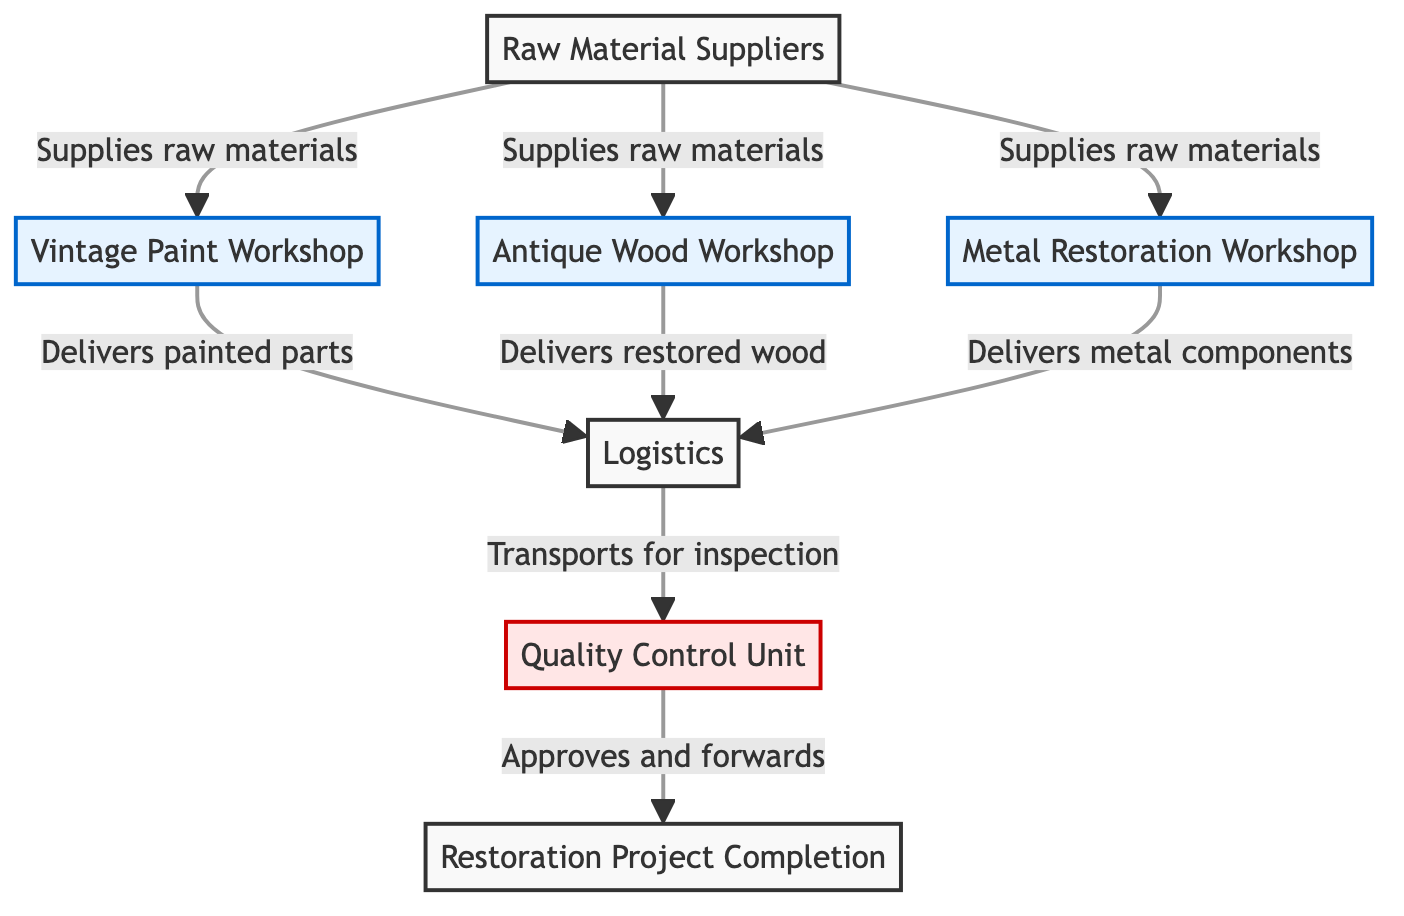What are the main components in the restoration food chain? The diagram includes four main components: Raw Material Suppliers, three workshops (Vintage Paint Workshop, Antique Wood Workshop, Metal Restoration Workshop), Logistics, and Quality Control Unit leading to the Restoration Project Completion.
Answer: Raw Material Suppliers, Vintage Paint Workshop, Antique Wood Workshop, Metal Restoration Workshop, Logistics, Quality Control Unit, Restoration Project Completion How many workshops are listed in the food chain? The diagram shows three distinct workshops: Vintage Paint Workshop, Antique Wood Workshop, and Metal Restoration Workshop, indicated by different labeled nodes.
Answer: 3 What does the Logistics node do in the diagram? The Logistics node receives deliveries from the workshops and is responsible for transporting the materials for inspection by the Quality Control Unit.
Answer: Transports for inspection Which workshop directly delivers painted parts? The Vintage Paint Workshop is specifically indicated in the diagram as the workshop that delivers painted parts to the logistics node.
Answer: Vintage Paint Workshop What is the role of the Quality Control Unit? The Quality Control Unit's role is to inspect, approve, and forward the materials received from Logistics to the final restoration project.
Answer: Approves and forwards Which node is the final output of the food chain? The final output in the flow of the diagram, where everything converges, is labeled as Restoration Project Completion.
Answer: Restoration Project Completion What flows from the Raw Material Suppliers to the Antique Wood Workshop? The flow indicated from Raw Material Suppliers to the Antique Wood Workshop shows that they supply raw materials necessary for the restoration processes conducted in the workshop.
Answer: Supplies raw materials Which two workshops deliver their output to the Logistics? The outputs from both the Vintage Paint Workshop and the Antique Wood Workshop are delivered to the Logistics, connecting these workshops to the next stage in the food chain.
Answer: Vintage Paint Workshop, Antique Wood Workshop What is the connection between Quality Control and the final output? Quality Control is directly connected to the final output, as it inspects and gives approval for the materials before they are finalized in the Restoration Project Completion.
Answer: Inspects and approves 